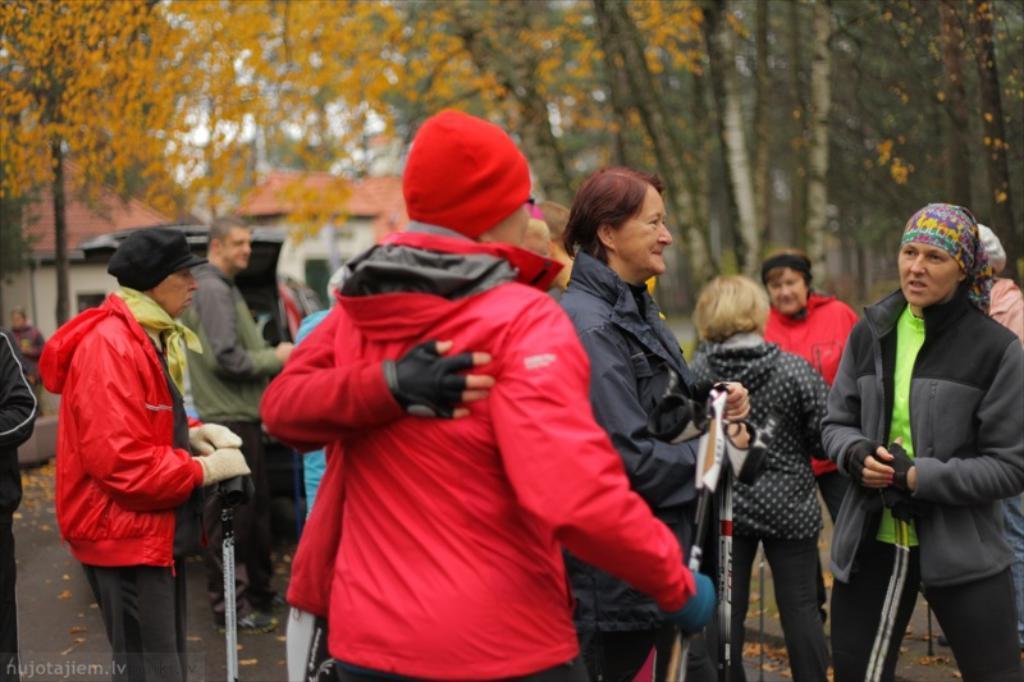Describe this image in one or two sentences. In this picture, we see the people are standing. Three of them are holding the sticks in their hands. In the background, we see the trees and buildings in white color with an orange color roof. This picture is blurred in the background. At the bottom, we see the road and the dry leaves. 